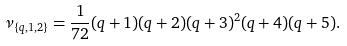Convert formula to latex. <formula><loc_0><loc_0><loc_500><loc_500>\nu _ { \{ q , 1 , 2 \} } = \frac { 1 } { 7 2 } ( q + 1 ) ( q + 2 ) ( q + 3 ) ^ { 2 } ( q + 4 ) ( q + 5 ) .</formula> 